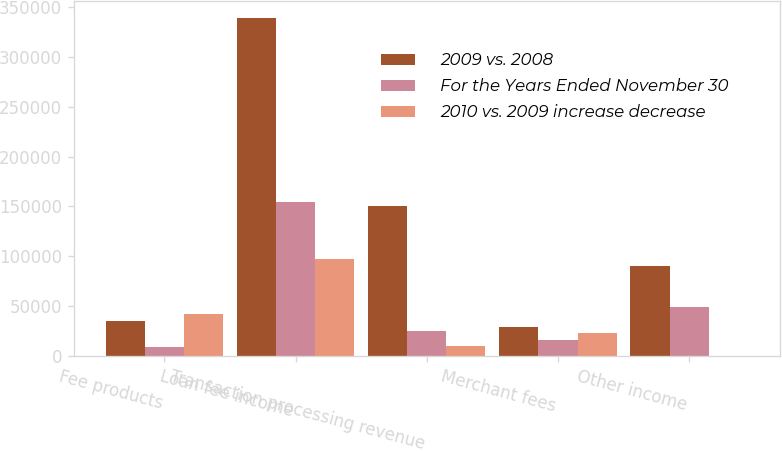Convert chart to OTSL. <chart><loc_0><loc_0><loc_500><loc_500><stacked_bar_chart><ecel><fcel>Fee products<fcel>Loan fee income<fcel>Transaction processing revenue<fcel>Merchant fees<fcel>Other income<nl><fcel>2009 vs. 2008<fcel>35145<fcel>339797<fcel>149946<fcel>28461<fcel>89808<nl><fcel>For the Years Ended November 30<fcel>9251<fcel>154508<fcel>24745<fcel>15787<fcel>48994<nl><fcel>2010 vs. 2009 increase decrease<fcel>41829<fcel>96874<fcel>9287<fcel>22779<fcel>179<nl></chart> 